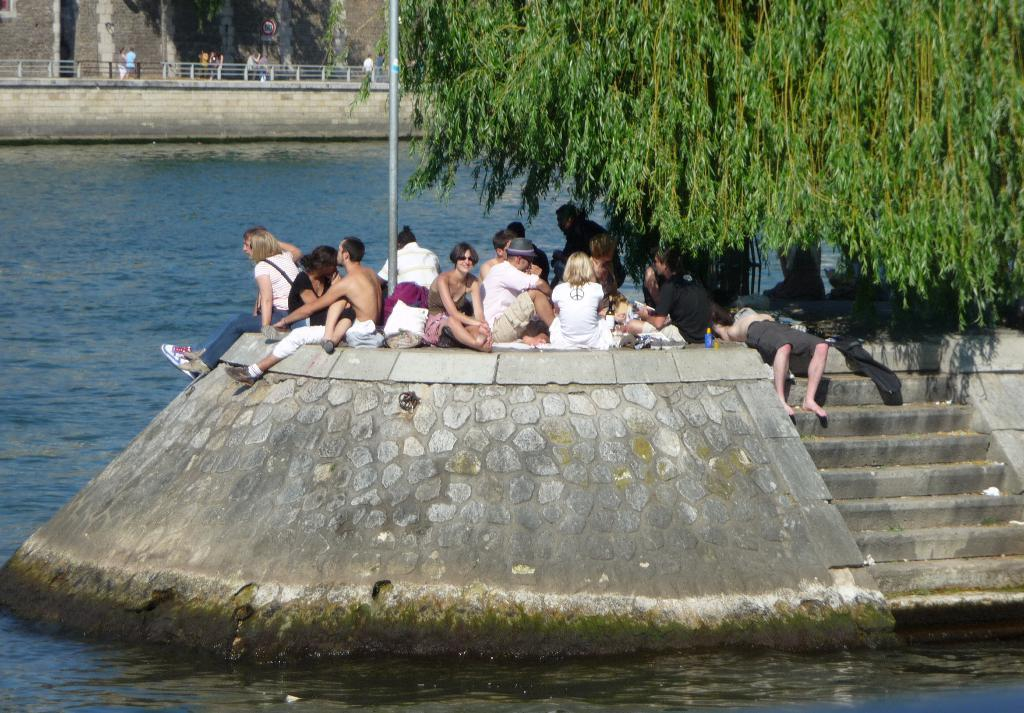What are the people in the image doing? There is a group of people sitting on a platform in the image. What can be seen in the image besides the people on the platform? There is a tree, steps, and water visible in the image. What is visible in the background of the image? In the background of the image, there are people, a signboard, and a wall. Can you describe the farmer in the image? There is no farmer present in the image. What type of ghost can be seen interacting with the people on the platform? There is no ghost present in the image; only the group of people, tree, steps, water, background people, signboard, and wall are visible. 